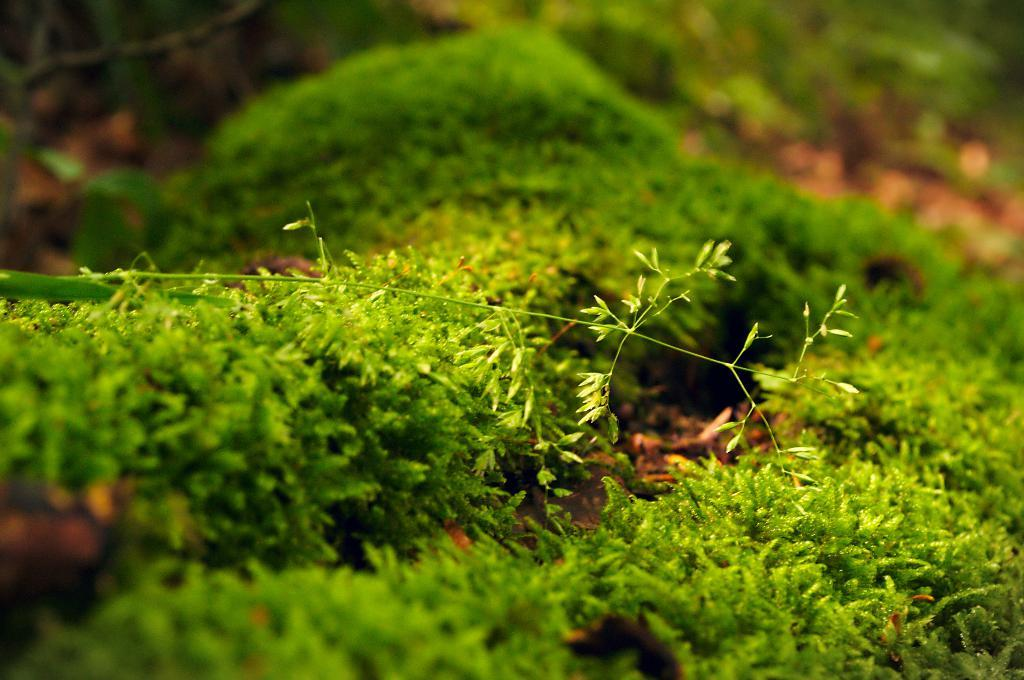What type of vegetation is in the center of the image? There is grass in the center of the image. What type of pie is being served in the image? There is no pie present in the image; it only features grass in the center. What subject is being taught in the image? There is no learning or teaching activity depicted in the image; it only features grass in the center. 